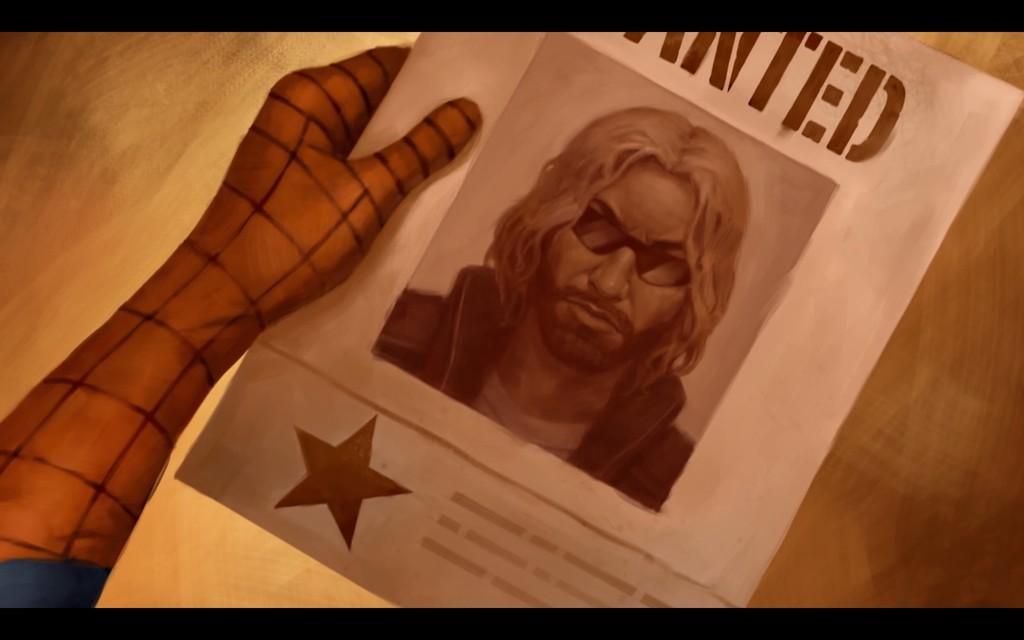What kind of poster is this?
Provide a short and direct response. Wanted. What is the last letter at the top?
Keep it short and to the point. D. 